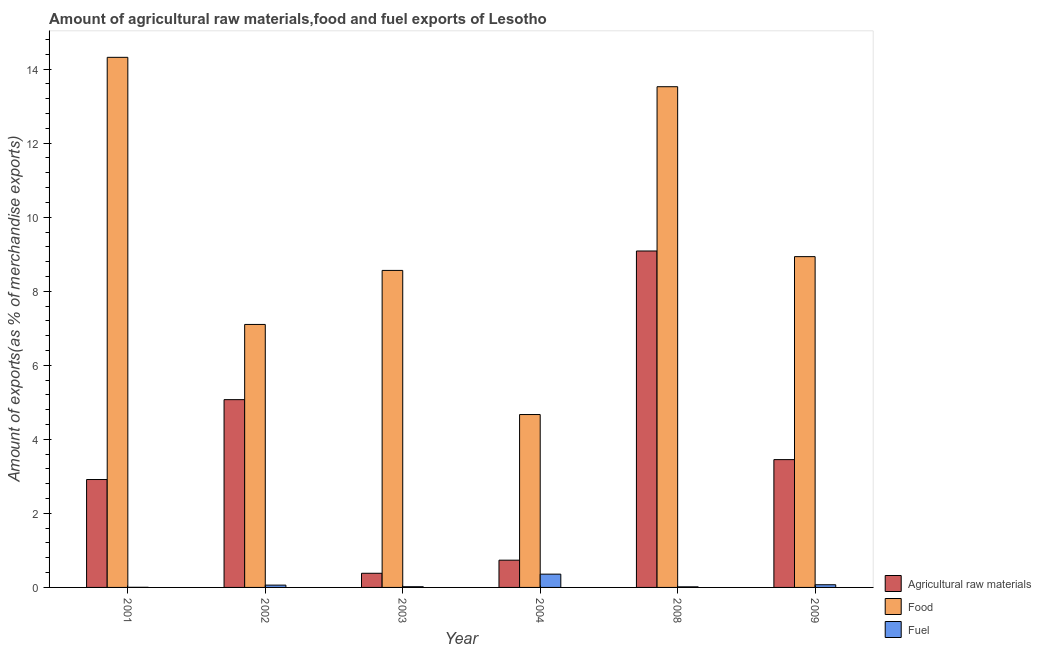Are the number of bars per tick equal to the number of legend labels?
Provide a succinct answer. Yes. Are the number of bars on each tick of the X-axis equal?
Offer a very short reply. Yes. How many bars are there on the 2nd tick from the right?
Ensure brevity in your answer.  3. What is the label of the 3rd group of bars from the left?
Make the answer very short. 2003. What is the percentage of fuel exports in 2009?
Ensure brevity in your answer.  0.07. Across all years, what is the maximum percentage of raw materials exports?
Provide a short and direct response. 9.09. Across all years, what is the minimum percentage of food exports?
Make the answer very short. 4.67. In which year was the percentage of raw materials exports minimum?
Your answer should be compact. 2003. What is the total percentage of fuel exports in the graph?
Offer a terse response. 0.53. What is the difference between the percentage of raw materials exports in 2004 and that in 2009?
Your answer should be very brief. -2.72. What is the difference between the percentage of fuel exports in 2008 and the percentage of raw materials exports in 2002?
Your answer should be very brief. -0.05. What is the average percentage of fuel exports per year?
Ensure brevity in your answer.  0.09. In how many years, is the percentage of raw materials exports greater than 10 %?
Provide a short and direct response. 0. What is the ratio of the percentage of food exports in 2001 to that in 2002?
Provide a short and direct response. 2.02. Is the percentage of fuel exports in 2002 less than that in 2004?
Provide a short and direct response. Yes. What is the difference between the highest and the second highest percentage of raw materials exports?
Make the answer very short. 4.02. What is the difference between the highest and the lowest percentage of raw materials exports?
Give a very brief answer. 8.7. Is the sum of the percentage of fuel exports in 2003 and 2009 greater than the maximum percentage of food exports across all years?
Ensure brevity in your answer.  No. What does the 1st bar from the left in 2001 represents?
Make the answer very short. Agricultural raw materials. What does the 2nd bar from the right in 2002 represents?
Provide a short and direct response. Food. Are all the bars in the graph horizontal?
Offer a terse response. No. Does the graph contain any zero values?
Give a very brief answer. No. Where does the legend appear in the graph?
Provide a short and direct response. Bottom right. What is the title of the graph?
Offer a very short reply. Amount of agricultural raw materials,food and fuel exports of Lesotho. What is the label or title of the Y-axis?
Provide a succinct answer. Amount of exports(as % of merchandise exports). What is the Amount of exports(as % of merchandise exports) of Agricultural raw materials in 2001?
Offer a very short reply. 2.91. What is the Amount of exports(as % of merchandise exports) in Food in 2001?
Offer a terse response. 14.32. What is the Amount of exports(as % of merchandise exports) in Fuel in 2001?
Make the answer very short. 0. What is the Amount of exports(as % of merchandise exports) of Agricultural raw materials in 2002?
Your answer should be compact. 5.07. What is the Amount of exports(as % of merchandise exports) in Food in 2002?
Keep it short and to the point. 7.1. What is the Amount of exports(as % of merchandise exports) of Fuel in 2002?
Your response must be concise. 0.06. What is the Amount of exports(as % of merchandise exports) of Agricultural raw materials in 2003?
Offer a very short reply. 0.38. What is the Amount of exports(as % of merchandise exports) of Food in 2003?
Offer a very short reply. 8.56. What is the Amount of exports(as % of merchandise exports) of Fuel in 2003?
Give a very brief answer. 0.02. What is the Amount of exports(as % of merchandise exports) of Agricultural raw materials in 2004?
Keep it short and to the point. 0.74. What is the Amount of exports(as % of merchandise exports) of Food in 2004?
Your answer should be compact. 4.67. What is the Amount of exports(as % of merchandise exports) in Fuel in 2004?
Provide a short and direct response. 0.36. What is the Amount of exports(as % of merchandise exports) of Agricultural raw materials in 2008?
Provide a succinct answer. 9.09. What is the Amount of exports(as % of merchandise exports) in Food in 2008?
Provide a succinct answer. 13.52. What is the Amount of exports(as % of merchandise exports) in Fuel in 2008?
Provide a succinct answer. 0.02. What is the Amount of exports(as % of merchandise exports) of Agricultural raw materials in 2009?
Give a very brief answer. 3.45. What is the Amount of exports(as % of merchandise exports) in Food in 2009?
Your answer should be compact. 8.93. What is the Amount of exports(as % of merchandise exports) in Fuel in 2009?
Your response must be concise. 0.07. Across all years, what is the maximum Amount of exports(as % of merchandise exports) of Agricultural raw materials?
Make the answer very short. 9.09. Across all years, what is the maximum Amount of exports(as % of merchandise exports) in Food?
Keep it short and to the point. 14.32. Across all years, what is the maximum Amount of exports(as % of merchandise exports) in Fuel?
Keep it short and to the point. 0.36. Across all years, what is the minimum Amount of exports(as % of merchandise exports) in Agricultural raw materials?
Make the answer very short. 0.38. Across all years, what is the minimum Amount of exports(as % of merchandise exports) of Food?
Ensure brevity in your answer.  4.67. Across all years, what is the minimum Amount of exports(as % of merchandise exports) in Fuel?
Keep it short and to the point. 0. What is the total Amount of exports(as % of merchandise exports) of Agricultural raw materials in the graph?
Keep it short and to the point. 21.64. What is the total Amount of exports(as % of merchandise exports) in Food in the graph?
Provide a short and direct response. 57.11. What is the total Amount of exports(as % of merchandise exports) in Fuel in the graph?
Provide a short and direct response. 0.53. What is the difference between the Amount of exports(as % of merchandise exports) of Agricultural raw materials in 2001 and that in 2002?
Give a very brief answer. -2.16. What is the difference between the Amount of exports(as % of merchandise exports) in Food in 2001 and that in 2002?
Give a very brief answer. 7.21. What is the difference between the Amount of exports(as % of merchandise exports) in Fuel in 2001 and that in 2002?
Your answer should be compact. -0.06. What is the difference between the Amount of exports(as % of merchandise exports) in Agricultural raw materials in 2001 and that in 2003?
Provide a succinct answer. 2.53. What is the difference between the Amount of exports(as % of merchandise exports) in Food in 2001 and that in 2003?
Offer a terse response. 5.76. What is the difference between the Amount of exports(as % of merchandise exports) of Fuel in 2001 and that in 2003?
Give a very brief answer. -0.02. What is the difference between the Amount of exports(as % of merchandise exports) in Agricultural raw materials in 2001 and that in 2004?
Your answer should be very brief. 2.18. What is the difference between the Amount of exports(as % of merchandise exports) in Food in 2001 and that in 2004?
Provide a short and direct response. 9.65. What is the difference between the Amount of exports(as % of merchandise exports) of Fuel in 2001 and that in 2004?
Provide a short and direct response. -0.36. What is the difference between the Amount of exports(as % of merchandise exports) of Agricultural raw materials in 2001 and that in 2008?
Your answer should be compact. -6.17. What is the difference between the Amount of exports(as % of merchandise exports) in Food in 2001 and that in 2008?
Ensure brevity in your answer.  0.79. What is the difference between the Amount of exports(as % of merchandise exports) in Fuel in 2001 and that in 2008?
Your answer should be very brief. -0.01. What is the difference between the Amount of exports(as % of merchandise exports) in Agricultural raw materials in 2001 and that in 2009?
Ensure brevity in your answer.  -0.54. What is the difference between the Amount of exports(as % of merchandise exports) of Food in 2001 and that in 2009?
Your response must be concise. 5.38. What is the difference between the Amount of exports(as % of merchandise exports) in Fuel in 2001 and that in 2009?
Your answer should be compact. -0.07. What is the difference between the Amount of exports(as % of merchandise exports) in Agricultural raw materials in 2002 and that in 2003?
Provide a succinct answer. 4.69. What is the difference between the Amount of exports(as % of merchandise exports) in Food in 2002 and that in 2003?
Ensure brevity in your answer.  -1.46. What is the difference between the Amount of exports(as % of merchandise exports) in Fuel in 2002 and that in 2003?
Your answer should be very brief. 0.04. What is the difference between the Amount of exports(as % of merchandise exports) of Agricultural raw materials in 2002 and that in 2004?
Your answer should be very brief. 4.34. What is the difference between the Amount of exports(as % of merchandise exports) of Food in 2002 and that in 2004?
Provide a short and direct response. 2.43. What is the difference between the Amount of exports(as % of merchandise exports) in Fuel in 2002 and that in 2004?
Ensure brevity in your answer.  -0.3. What is the difference between the Amount of exports(as % of merchandise exports) of Agricultural raw materials in 2002 and that in 2008?
Make the answer very short. -4.02. What is the difference between the Amount of exports(as % of merchandise exports) of Food in 2002 and that in 2008?
Keep it short and to the point. -6.42. What is the difference between the Amount of exports(as % of merchandise exports) of Fuel in 2002 and that in 2008?
Ensure brevity in your answer.  0.05. What is the difference between the Amount of exports(as % of merchandise exports) in Agricultural raw materials in 2002 and that in 2009?
Give a very brief answer. 1.62. What is the difference between the Amount of exports(as % of merchandise exports) in Food in 2002 and that in 2009?
Your response must be concise. -1.83. What is the difference between the Amount of exports(as % of merchandise exports) in Fuel in 2002 and that in 2009?
Your answer should be compact. -0.01. What is the difference between the Amount of exports(as % of merchandise exports) in Agricultural raw materials in 2003 and that in 2004?
Your answer should be compact. -0.35. What is the difference between the Amount of exports(as % of merchandise exports) in Food in 2003 and that in 2004?
Offer a terse response. 3.89. What is the difference between the Amount of exports(as % of merchandise exports) in Fuel in 2003 and that in 2004?
Offer a terse response. -0.34. What is the difference between the Amount of exports(as % of merchandise exports) in Agricultural raw materials in 2003 and that in 2008?
Offer a terse response. -8.7. What is the difference between the Amount of exports(as % of merchandise exports) in Food in 2003 and that in 2008?
Provide a succinct answer. -4.96. What is the difference between the Amount of exports(as % of merchandise exports) of Fuel in 2003 and that in 2008?
Offer a terse response. 0. What is the difference between the Amount of exports(as % of merchandise exports) of Agricultural raw materials in 2003 and that in 2009?
Provide a succinct answer. -3.07. What is the difference between the Amount of exports(as % of merchandise exports) of Food in 2003 and that in 2009?
Ensure brevity in your answer.  -0.37. What is the difference between the Amount of exports(as % of merchandise exports) of Fuel in 2003 and that in 2009?
Ensure brevity in your answer.  -0.05. What is the difference between the Amount of exports(as % of merchandise exports) in Agricultural raw materials in 2004 and that in 2008?
Give a very brief answer. -8.35. What is the difference between the Amount of exports(as % of merchandise exports) of Food in 2004 and that in 2008?
Provide a succinct answer. -8.85. What is the difference between the Amount of exports(as % of merchandise exports) in Fuel in 2004 and that in 2008?
Make the answer very short. 0.34. What is the difference between the Amount of exports(as % of merchandise exports) of Agricultural raw materials in 2004 and that in 2009?
Ensure brevity in your answer.  -2.72. What is the difference between the Amount of exports(as % of merchandise exports) in Food in 2004 and that in 2009?
Keep it short and to the point. -4.27. What is the difference between the Amount of exports(as % of merchandise exports) in Fuel in 2004 and that in 2009?
Your response must be concise. 0.29. What is the difference between the Amount of exports(as % of merchandise exports) of Agricultural raw materials in 2008 and that in 2009?
Keep it short and to the point. 5.63. What is the difference between the Amount of exports(as % of merchandise exports) in Food in 2008 and that in 2009?
Your response must be concise. 4.59. What is the difference between the Amount of exports(as % of merchandise exports) in Fuel in 2008 and that in 2009?
Provide a short and direct response. -0.06. What is the difference between the Amount of exports(as % of merchandise exports) of Agricultural raw materials in 2001 and the Amount of exports(as % of merchandise exports) of Food in 2002?
Provide a short and direct response. -4.19. What is the difference between the Amount of exports(as % of merchandise exports) of Agricultural raw materials in 2001 and the Amount of exports(as % of merchandise exports) of Fuel in 2002?
Your answer should be very brief. 2.85. What is the difference between the Amount of exports(as % of merchandise exports) of Food in 2001 and the Amount of exports(as % of merchandise exports) of Fuel in 2002?
Make the answer very short. 14.26. What is the difference between the Amount of exports(as % of merchandise exports) in Agricultural raw materials in 2001 and the Amount of exports(as % of merchandise exports) in Food in 2003?
Offer a very short reply. -5.65. What is the difference between the Amount of exports(as % of merchandise exports) in Agricultural raw materials in 2001 and the Amount of exports(as % of merchandise exports) in Fuel in 2003?
Provide a short and direct response. 2.9. What is the difference between the Amount of exports(as % of merchandise exports) of Food in 2001 and the Amount of exports(as % of merchandise exports) of Fuel in 2003?
Provide a succinct answer. 14.3. What is the difference between the Amount of exports(as % of merchandise exports) of Agricultural raw materials in 2001 and the Amount of exports(as % of merchandise exports) of Food in 2004?
Make the answer very short. -1.76. What is the difference between the Amount of exports(as % of merchandise exports) in Agricultural raw materials in 2001 and the Amount of exports(as % of merchandise exports) in Fuel in 2004?
Make the answer very short. 2.56. What is the difference between the Amount of exports(as % of merchandise exports) of Food in 2001 and the Amount of exports(as % of merchandise exports) of Fuel in 2004?
Your answer should be very brief. 13.96. What is the difference between the Amount of exports(as % of merchandise exports) in Agricultural raw materials in 2001 and the Amount of exports(as % of merchandise exports) in Food in 2008?
Your answer should be very brief. -10.61. What is the difference between the Amount of exports(as % of merchandise exports) of Agricultural raw materials in 2001 and the Amount of exports(as % of merchandise exports) of Fuel in 2008?
Provide a succinct answer. 2.9. What is the difference between the Amount of exports(as % of merchandise exports) in Food in 2001 and the Amount of exports(as % of merchandise exports) in Fuel in 2008?
Your answer should be compact. 14.3. What is the difference between the Amount of exports(as % of merchandise exports) in Agricultural raw materials in 2001 and the Amount of exports(as % of merchandise exports) in Food in 2009?
Your answer should be compact. -6.02. What is the difference between the Amount of exports(as % of merchandise exports) in Agricultural raw materials in 2001 and the Amount of exports(as % of merchandise exports) in Fuel in 2009?
Your answer should be compact. 2.84. What is the difference between the Amount of exports(as % of merchandise exports) of Food in 2001 and the Amount of exports(as % of merchandise exports) of Fuel in 2009?
Keep it short and to the point. 14.25. What is the difference between the Amount of exports(as % of merchandise exports) in Agricultural raw materials in 2002 and the Amount of exports(as % of merchandise exports) in Food in 2003?
Offer a very short reply. -3.49. What is the difference between the Amount of exports(as % of merchandise exports) in Agricultural raw materials in 2002 and the Amount of exports(as % of merchandise exports) in Fuel in 2003?
Your answer should be very brief. 5.05. What is the difference between the Amount of exports(as % of merchandise exports) in Food in 2002 and the Amount of exports(as % of merchandise exports) in Fuel in 2003?
Ensure brevity in your answer.  7.08. What is the difference between the Amount of exports(as % of merchandise exports) in Agricultural raw materials in 2002 and the Amount of exports(as % of merchandise exports) in Food in 2004?
Keep it short and to the point. 0.4. What is the difference between the Amount of exports(as % of merchandise exports) of Agricultural raw materials in 2002 and the Amount of exports(as % of merchandise exports) of Fuel in 2004?
Offer a very short reply. 4.71. What is the difference between the Amount of exports(as % of merchandise exports) in Food in 2002 and the Amount of exports(as % of merchandise exports) in Fuel in 2004?
Your answer should be very brief. 6.74. What is the difference between the Amount of exports(as % of merchandise exports) of Agricultural raw materials in 2002 and the Amount of exports(as % of merchandise exports) of Food in 2008?
Provide a short and direct response. -8.45. What is the difference between the Amount of exports(as % of merchandise exports) of Agricultural raw materials in 2002 and the Amount of exports(as % of merchandise exports) of Fuel in 2008?
Offer a terse response. 5.06. What is the difference between the Amount of exports(as % of merchandise exports) in Food in 2002 and the Amount of exports(as % of merchandise exports) in Fuel in 2008?
Offer a very short reply. 7.09. What is the difference between the Amount of exports(as % of merchandise exports) in Agricultural raw materials in 2002 and the Amount of exports(as % of merchandise exports) in Food in 2009?
Your answer should be very brief. -3.86. What is the difference between the Amount of exports(as % of merchandise exports) in Agricultural raw materials in 2002 and the Amount of exports(as % of merchandise exports) in Fuel in 2009?
Offer a very short reply. 5. What is the difference between the Amount of exports(as % of merchandise exports) of Food in 2002 and the Amount of exports(as % of merchandise exports) of Fuel in 2009?
Offer a very short reply. 7.03. What is the difference between the Amount of exports(as % of merchandise exports) in Agricultural raw materials in 2003 and the Amount of exports(as % of merchandise exports) in Food in 2004?
Your answer should be very brief. -4.29. What is the difference between the Amount of exports(as % of merchandise exports) of Agricultural raw materials in 2003 and the Amount of exports(as % of merchandise exports) of Fuel in 2004?
Your response must be concise. 0.02. What is the difference between the Amount of exports(as % of merchandise exports) in Food in 2003 and the Amount of exports(as % of merchandise exports) in Fuel in 2004?
Provide a short and direct response. 8.2. What is the difference between the Amount of exports(as % of merchandise exports) in Agricultural raw materials in 2003 and the Amount of exports(as % of merchandise exports) in Food in 2008?
Provide a succinct answer. -13.14. What is the difference between the Amount of exports(as % of merchandise exports) of Agricultural raw materials in 2003 and the Amount of exports(as % of merchandise exports) of Fuel in 2008?
Ensure brevity in your answer.  0.37. What is the difference between the Amount of exports(as % of merchandise exports) of Food in 2003 and the Amount of exports(as % of merchandise exports) of Fuel in 2008?
Keep it short and to the point. 8.55. What is the difference between the Amount of exports(as % of merchandise exports) of Agricultural raw materials in 2003 and the Amount of exports(as % of merchandise exports) of Food in 2009?
Ensure brevity in your answer.  -8.55. What is the difference between the Amount of exports(as % of merchandise exports) in Agricultural raw materials in 2003 and the Amount of exports(as % of merchandise exports) in Fuel in 2009?
Give a very brief answer. 0.31. What is the difference between the Amount of exports(as % of merchandise exports) of Food in 2003 and the Amount of exports(as % of merchandise exports) of Fuel in 2009?
Provide a succinct answer. 8.49. What is the difference between the Amount of exports(as % of merchandise exports) in Agricultural raw materials in 2004 and the Amount of exports(as % of merchandise exports) in Food in 2008?
Your response must be concise. -12.79. What is the difference between the Amount of exports(as % of merchandise exports) in Agricultural raw materials in 2004 and the Amount of exports(as % of merchandise exports) in Fuel in 2008?
Provide a succinct answer. 0.72. What is the difference between the Amount of exports(as % of merchandise exports) of Food in 2004 and the Amount of exports(as % of merchandise exports) of Fuel in 2008?
Give a very brief answer. 4.65. What is the difference between the Amount of exports(as % of merchandise exports) of Agricultural raw materials in 2004 and the Amount of exports(as % of merchandise exports) of Food in 2009?
Ensure brevity in your answer.  -8.2. What is the difference between the Amount of exports(as % of merchandise exports) of Agricultural raw materials in 2004 and the Amount of exports(as % of merchandise exports) of Fuel in 2009?
Your answer should be very brief. 0.66. What is the difference between the Amount of exports(as % of merchandise exports) of Food in 2004 and the Amount of exports(as % of merchandise exports) of Fuel in 2009?
Offer a terse response. 4.6. What is the difference between the Amount of exports(as % of merchandise exports) of Agricultural raw materials in 2008 and the Amount of exports(as % of merchandise exports) of Food in 2009?
Give a very brief answer. 0.15. What is the difference between the Amount of exports(as % of merchandise exports) in Agricultural raw materials in 2008 and the Amount of exports(as % of merchandise exports) in Fuel in 2009?
Give a very brief answer. 9.01. What is the difference between the Amount of exports(as % of merchandise exports) in Food in 2008 and the Amount of exports(as % of merchandise exports) in Fuel in 2009?
Offer a terse response. 13.45. What is the average Amount of exports(as % of merchandise exports) in Agricultural raw materials per year?
Give a very brief answer. 3.61. What is the average Amount of exports(as % of merchandise exports) in Food per year?
Keep it short and to the point. 9.52. What is the average Amount of exports(as % of merchandise exports) in Fuel per year?
Your answer should be compact. 0.09. In the year 2001, what is the difference between the Amount of exports(as % of merchandise exports) in Agricultural raw materials and Amount of exports(as % of merchandise exports) in Food?
Provide a succinct answer. -11.4. In the year 2001, what is the difference between the Amount of exports(as % of merchandise exports) in Agricultural raw materials and Amount of exports(as % of merchandise exports) in Fuel?
Make the answer very short. 2.91. In the year 2001, what is the difference between the Amount of exports(as % of merchandise exports) in Food and Amount of exports(as % of merchandise exports) in Fuel?
Offer a terse response. 14.31. In the year 2002, what is the difference between the Amount of exports(as % of merchandise exports) of Agricultural raw materials and Amount of exports(as % of merchandise exports) of Food?
Provide a short and direct response. -2.03. In the year 2002, what is the difference between the Amount of exports(as % of merchandise exports) in Agricultural raw materials and Amount of exports(as % of merchandise exports) in Fuel?
Your answer should be compact. 5.01. In the year 2002, what is the difference between the Amount of exports(as % of merchandise exports) of Food and Amount of exports(as % of merchandise exports) of Fuel?
Ensure brevity in your answer.  7.04. In the year 2003, what is the difference between the Amount of exports(as % of merchandise exports) of Agricultural raw materials and Amount of exports(as % of merchandise exports) of Food?
Provide a succinct answer. -8.18. In the year 2003, what is the difference between the Amount of exports(as % of merchandise exports) in Agricultural raw materials and Amount of exports(as % of merchandise exports) in Fuel?
Provide a succinct answer. 0.36. In the year 2003, what is the difference between the Amount of exports(as % of merchandise exports) in Food and Amount of exports(as % of merchandise exports) in Fuel?
Keep it short and to the point. 8.54. In the year 2004, what is the difference between the Amount of exports(as % of merchandise exports) in Agricultural raw materials and Amount of exports(as % of merchandise exports) in Food?
Offer a terse response. -3.93. In the year 2004, what is the difference between the Amount of exports(as % of merchandise exports) in Agricultural raw materials and Amount of exports(as % of merchandise exports) in Fuel?
Your answer should be compact. 0.38. In the year 2004, what is the difference between the Amount of exports(as % of merchandise exports) of Food and Amount of exports(as % of merchandise exports) of Fuel?
Your answer should be very brief. 4.31. In the year 2008, what is the difference between the Amount of exports(as % of merchandise exports) of Agricultural raw materials and Amount of exports(as % of merchandise exports) of Food?
Offer a terse response. -4.44. In the year 2008, what is the difference between the Amount of exports(as % of merchandise exports) of Agricultural raw materials and Amount of exports(as % of merchandise exports) of Fuel?
Offer a very short reply. 9.07. In the year 2008, what is the difference between the Amount of exports(as % of merchandise exports) of Food and Amount of exports(as % of merchandise exports) of Fuel?
Make the answer very short. 13.51. In the year 2009, what is the difference between the Amount of exports(as % of merchandise exports) of Agricultural raw materials and Amount of exports(as % of merchandise exports) of Food?
Give a very brief answer. -5.48. In the year 2009, what is the difference between the Amount of exports(as % of merchandise exports) in Agricultural raw materials and Amount of exports(as % of merchandise exports) in Fuel?
Your answer should be very brief. 3.38. In the year 2009, what is the difference between the Amount of exports(as % of merchandise exports) in Food and Amount of exports(as % of merchandise exports) in Fuel?
Your answer should be very brief. 8.86. What is the ratio of the Amount of exports(as % of merchandise exports) in Agricultural raw materials in 2001 to that in 2002?
Keep it short and to the point. 0.57. What is the ratio of the Amount of exports(as % of merchandise exports) of Food in 2001 to that in 2002?
Provide a succinct answer. 2.02. What is the ratio of the Amount of exports(as % of merchandise exports) in Fuel in 2001 to that in 2002?
Provide a short and direct response. 0.05. What is the ratio of the Amount of exports(as % of merchandise exports) in Agricultural raw materials in 2001 to that in 2003?
Your response must be concise. 7.62. What is the ratio of the Amount of exports(as % of merchandise exports) in Food in 2001 to that in 2003?
Ensure brevity in your answer.  1.67. What is the ratio of the Amount of exports(as % of merchandise exports) of Fuel in 2001 to that in 2003?
Provide a short and direct response. 0.18. What is the ratio of the Amount of exports(as % of merchandise exports) in Agricultural raw materials in 2001 to that in 2004?
Your answer should be very brief. 3.96. What is the ratio of the Amount of exports(as % of merchandise exports) of Food in 2001 to that in 2004?
Your response must be concise. 3.07. What is the ratio of the Amount of exports(as % of merchandise exports) of Fuel in 2001 to that in 2004?
Provide a succinct answer. 0.01. What is the ratio of the Amount of exports(as % of merchandise exports) in Agricultural raw materials in 2001 to that in 2008?
Your answer should be very brief. 0.32. What is the ratio of the Amount of exports(as % of merchandise exports) of Food in 2001 to that in 2008?
Make the answer very short. 1.06. What is the ratio of the Amount of exports(as % of merchandise exports) of Fuel in 2001 to that in 2008?
Provide a short and direct response. 0.21. What is the ratio of the Amount of exports(as % of merchandise exports) in Agricultural raw materials in 2001 to that in 2009?
Your answer should be compact. 0.84. What is the ratio of the Amount of exports(as % of merchandise exports) of Food in 2001 to that in 2009?
Your answer should be compact. 1.6. What is the ratio of the Amount of exports(as % of merchandise exports) in Fuel in 2001 to that in 2009?
Ensure brevity in your answer.  0.05. What is the ratio of the Amount of exports(as % of merchandise exports) of Agricultural raw materials in 2002 to that in 2003?
Provide a short and direct response. 13.26. What is the ratio of the Amount of exports(as % of merchandise exports) of Food in 2002 to that in 2003?
Give a very brief answer. 0.83. What is the ratio of the Amount of exports(as % of merchandise exports) of Fuel in 2002 to that in 2003?
Ensure brevity in your answer.  3.3. What is the ratio of the Amount of exports(as % of merchandise exports) of Agricultural raw materials in 2002 to that in 2004?
Provide a succinct answer. 6.89. What is the ratio of the Amount of exports(as % of merchandise exports) in Food in 2002 to that in 2004?
Your answer should be very brief. 1.52. What is the ratio of the Amount of exports(as % of merchandise exports) in Fuel in 2002 to that in 2004?
Offer a terse response. 0.17. What is the ratio of the Amount of exports(as % of merchandise exports) of Agricultural raw materials in 2002 to that in 2008?
Your answer should be compact. 0.56. What is the ratio of the Amount of exports(as % of merchandise exports) of Food in 2002 to that in 2008?
Offer a terse response. 0.53. What is the ratio of the Amount of exports(as % of merchandise exports) of Fuel in 2002 to that in 2008?
Your response must be concise. 3.92. What is the ratio of the Amount of exports(as % of merchandise exports) in Agricultural raw materials in 2002 to that in 2009?
Make the answer very short. 1.47. What is the ratio of the Amount of exports(as % of merchandise exports) of Food in 2002 to that in 2009?
Offer a very short reply. 0.8. What is the ratio of the Amount of exports(as % of merchandise exports) of Fuel in 2002 to that in 2009?
Keep it short and to the point. 0.86. What is the ratio of the Amount of exports(as % of merchandise exports) in Agricultural raw materials in 2003 to that in 2004?
Your answer should be very brief. 0.52. What is the ratio of the Amount of exports(as % of merchandise exports) of Food in 2003 to that in 2004?
Your answer should be compact. 1.83. What is the ratio of the Amount of exports(as % of merchandise exports) of Fuel in 2003 to that in 2004?
Provide a succinct answer. 0.05. What is the ratio of the Amount of exports(as % of merchandise exports) of Agricultural raw materials in 2003 to that in 2008?
Your answer should be very brief. 0.04. What is the ratio of the Amount of exports(as % of merchandise exports) in Food in 2003 to that in 2008?
Offer a very short reply. 0.63. What is the ratio of the Amount of exports(as % of merchandise exports) in Fuel in 2003 to that in 2008?
Your answer should be compact. 1.19. What is the ratio of the Amount of exports(as % of merchandise exports) in Agricultural raw materials in 2003 to that in 2009?
Ensure brevity in your answer.  0.11. What is the ratio of the Amount of exports(as % of merchandise exports) of Food in 2003 to that in 2009?
Offer a very short reply. 0.96. What is the ratio of the Amount of exports(as % of merchandise exports) in Fuel in 2003 to that in 2009?
Provide a short and direct response. 0.26. What is the ratio of the Amount of exports(as % of merchandise exports) of Agricultural raw materials in 2004 to that in 2008?
Make the answer very short. 0.08. What is the ratio of the Amount of exports(as % of merchandise exports) in Food in 2004 to that in 2008?
Your response must be concise. 0.35. What is the ratio of the Amount of exports(as % of merchandise exports) in Fuel in 2004 to that in 2008?
Offer a terse response. 22.53. What is the ratio of the Amount of exports(as % of merchandise exports) of Agricultural raw materials in 2004 to that in 2009?
Your response must be concise. 0.21. What is the ratio of the Amount of exports(as % of merchandise exports) of Food in 2004 to that in 2009?
Your response must be concise. 0.52. What is the ratio of the Amount of exports(as % of merchandise exports) of Fuel in 2004 to that in 2009?
Provide a short and direct response. 4.95. What is the ratio of the Amount of exports(as % of merchandise exports) of Agricultural raw materials in 2008 to that in 2009?
Keep it short and to the point. 2.63. What is the ratio of the Amount of exports(as % of merchandise exports) in Food in 2008 to that in 2009?
Provide a succinct answer. 1.51. What is the ratio of the Amount of exports(as % of merchandise exports) of Fuel in 2008 to that in 2009?
Keep it short and to the point. 0.22. What is the difference between the highest and the second highest Amount of exports(as % of merchandise exports) of Agricultural raw materials?
Ensure brevity in your answer.  4.02. What is the difference between the highest and the second highest Amount of exports(as % of merchandise exports) in Food?
Provide a short and direct response. 0.79. What is the difference between the highest and the second highest Amount of exports(as % of merchandise exports) of Fuel?
Your answer should be very brief. 0.29. What is the difference between the highest and the lowest Amount of exports(as % of merchandise exports) in Agricultural raw materials?
Keep it short and to the point. 8.7. What is the difference between the highest and the lowest Amount of exports(as % of merchandise exports) of Food?
Give a very brief answer. 9.65. What is the difference between the highest and the lowest Amount of exports(as % of merchandise exports) of Fuel?
Provide a short and direct response. 0.36. 